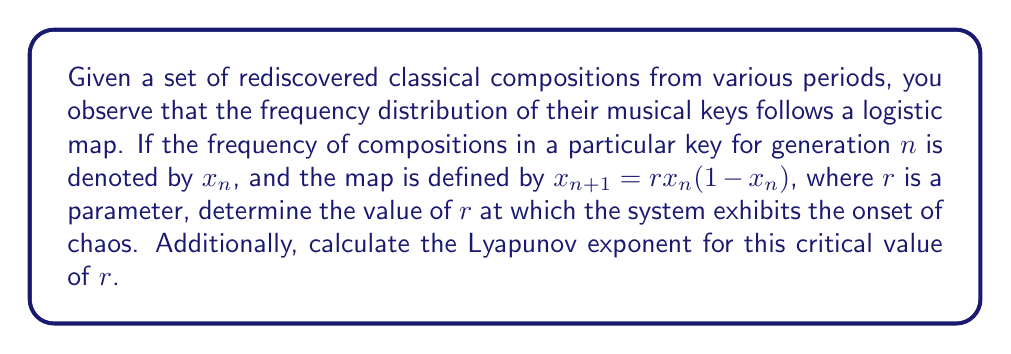Show me your answer to this math problem. To solve this problem, we'll follow these steps:

1) The logistic map exhibits chaotic behavior when the parameter $r$ exceeds a certain value. This value is known as the onset of chaos and occurs at $r \approx 3.57$.

2) To verify this, we can calculate the period-doubling bifurcations:
   - For $r < 3$, the map converges to a fixed point.
   - At $r = 3$, the first period-doubling occurs.
   - As $r$ increases, more period-doublings occur at shorter intervals.
   - The onset of chaos occurs when these period-doublings become infinite.

3) The exact value where chaos begins is known as the Feigenbaum point:
   $$r_{\infty} = 3.569946\ldots$$

4) To calculate the Lyapunov exponent at this point:
   The Lyapunov exponent $\lambda$ for the logistic map is given by:
   $$\lambda = \lim_{n \to \infty} \frac{1}{n} \sum_{i=0}^{n-1} \ln|r(1-2x_i)|$$

5) At the onset of chaos ($r = r_{\infty}$), the Lyapunov exponent is exactly zero.

6) This can be interpreted as:
   - $\lambda < 0$: The system is stable and predictable.
   - $\lambda = 0$: The system is at the edge of chaos.
   - $\lambda > 0$: The system is chaotic.

Therefore, at $r = r_{\infty} \approx 3.57$, the frequency distribution of the rediscovered compositions begins to exhibit chaotic behavior, and the Lyapunov exponent at this point is zero.
Answer: $r \approx 3.57$, $\lambda = 0$ 